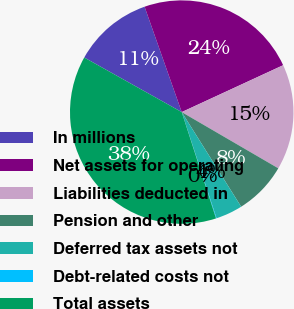Convert chart to OTSL. <chart><loc_0><loc_0><loc_500><loc_500><pie_chart><fcel>In millions<fcel>Net assets for operating<fcel>Liabilities deducted in<fcel>Pension and other<fcel>Deferred tax assets not<fcel>Debt-related costs not<fcel>Total assets<nl><fcel>11.48%<fcel>23.5%<fcel>15.28%<fcel>7.68%<fcel>3.88%<fcel>0.08%<fcel>38.08%<nl></chart> 